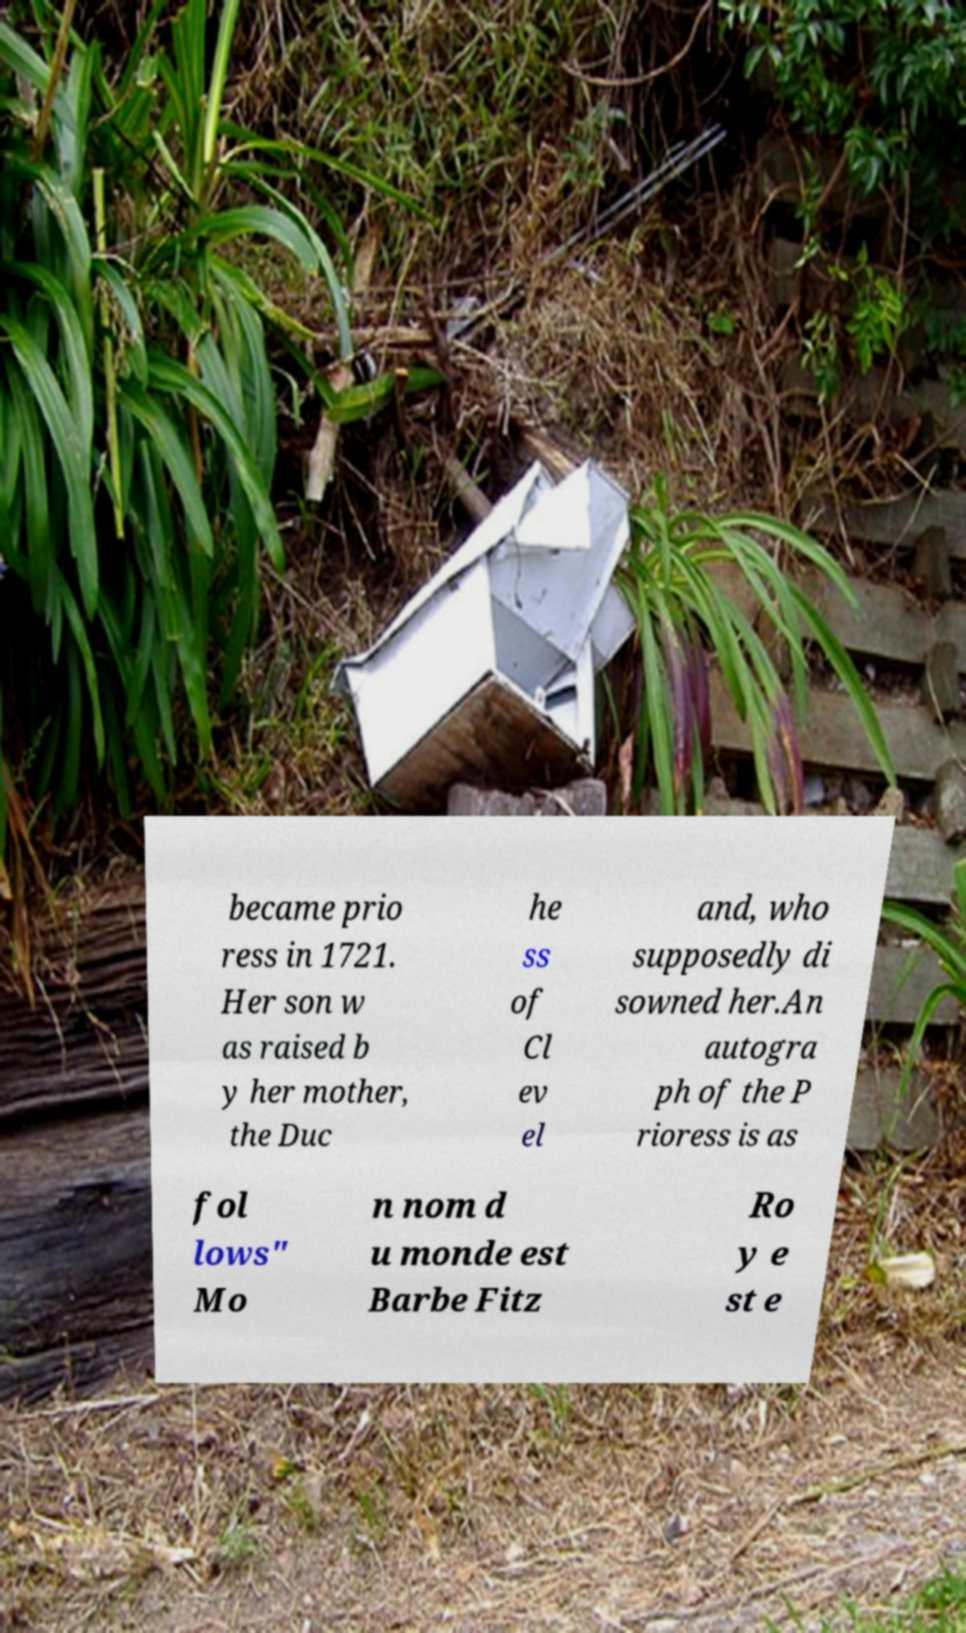Can you read and provide the text displayed in the image?This photo seems to have some interesting text. Can you extract and type it out for me? became prio ress in 1721. Her son w as raised b y her mother, the Duc he ss of Cl ev el and, who supposedly di sowned her.An autogra ph of the P rioress is as fol lows" Mo n nom d u monde est Barbe Fitz Ro y e st e 